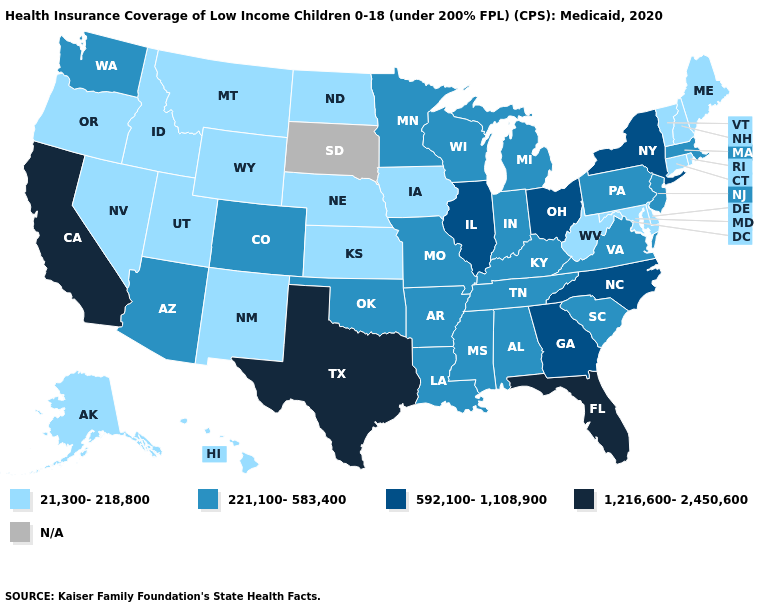Among the states that border Virginia , which have the lowest value?
Short answer required. Maryland, West Virginia. What is the value of California?
Give a very brief answer. 1,216,600-2,450,600. Does Alabama have the lowest value in the USA?
Answer briefly. No. What is the lowest value in states that border Pennsylvania?
Concise answer only. 21,300-218,800. What is the highest value in the South ?
Give a very brief answer. 1,216,600-2,450,600. Does the first symbol in the legend represent the smallest category?
Short answer required. Yes. Among the states that border Maryland , which have the lowest value?
Short answer required. Delaware, West Virginia. Name the states that have a value in the range 221,100-583,400?
Quick response, please. Alabama, Arizona, Arkansas, Colorado, Indiana, Kentucky, Louisiana, Massachusetts, Michigan, Minnesota, Mississippi, Missouri, New Jersey, Oklahoma, Pennsylvania, South Carolina, Tennessee, Virginia, Washington, Wisconsin. What is the value of Illinois?
Give a very brief answer. 592,100-1,108,900. How many symbols are there in the legend?
Short answer required. 5. Name the states that have a value in the range 592,100-1,108,900?
Short answer required. Georgia, Illinois, New York, North Carolina, Ohio. What is the value of West Virginia?
Be succinct. 21,300-218,800. What is the value of California?
Short answer required. 1,216,600-2,450,600. Among the states that border Maine , which have the lowest value?
Give a very brief answer. New Hampshire. 